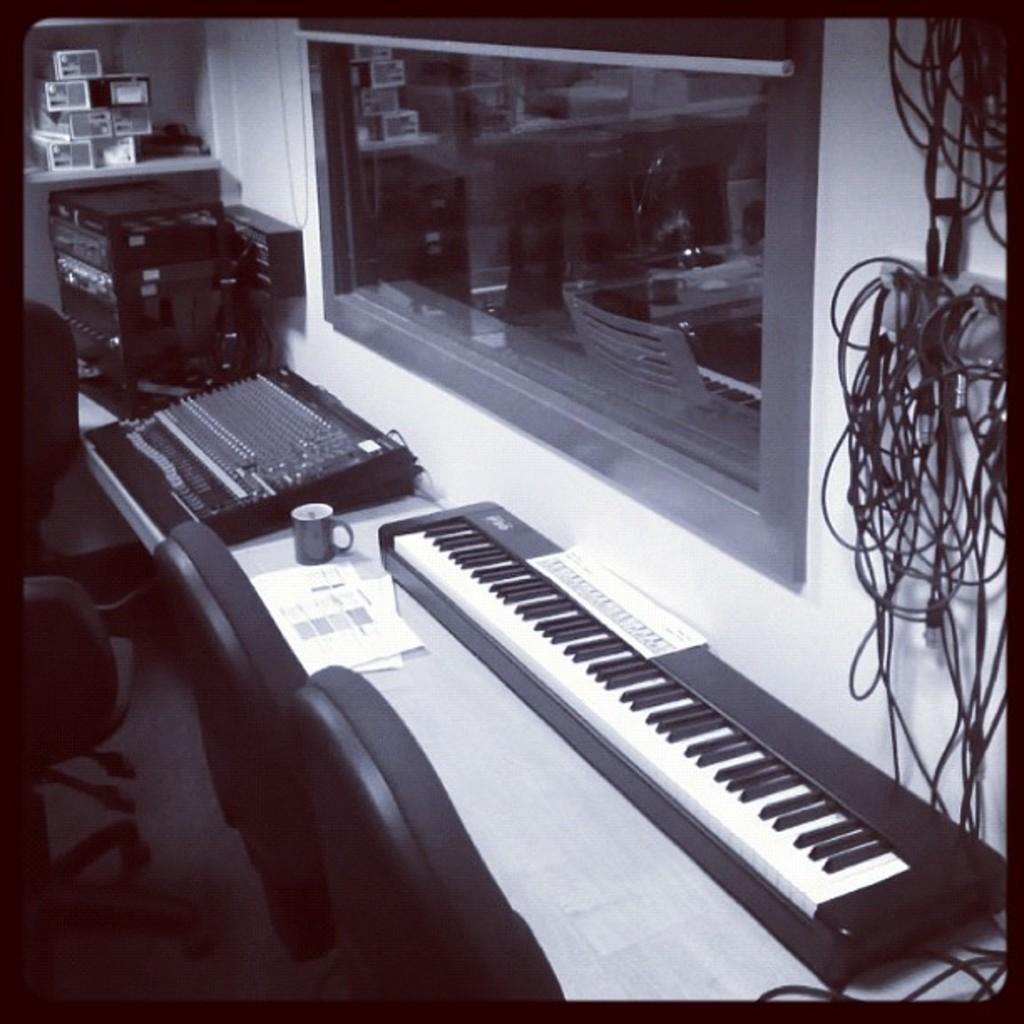Could you give a brief overview of what you see in this image? In this image, I can see a piano on the right side and there are some wires hanged, and on the left side I can see some chairs and there is a cup and papers on the table, in the middle I can see the glass window. 